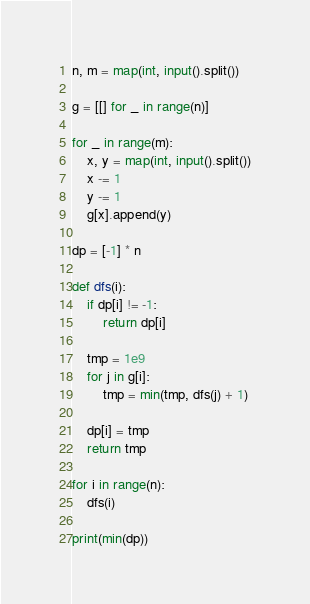<code> <loc_0><loc_0><loc_500><loc_500><_Python_>n, m = map(int, input().split())

g = [[] for _ in range(n)]

for _ in range(m):
    x, y = map(int, input().split())
    x -= 1
    y -= 1
    g[x].append(y)

dp = [-1] * n

def dfs(i):
    if dp[i] != -1:
        return dp[i]

    tmp = 1e9
    for j in g[i]:
        tmp = min(tmp, dfs(j) + 1)

    dp[i] = tmp
    return tmp

for i in range(n):
    dfs(i)

print(min(dp))

</code> 